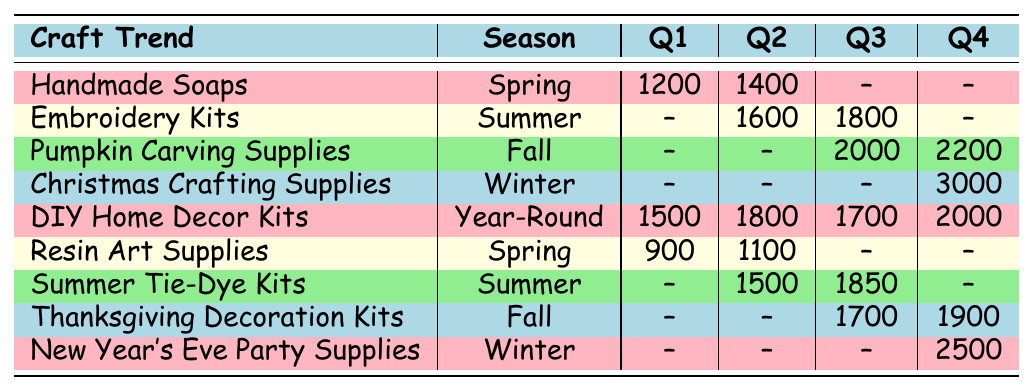What is the total sales of Handmade Soaps in Spring? From the table, we see that the sales for Handmade Soaps in Spring are listed as 1200 in Q1 and 1400 in Q2. Adding these together gives 1200 + 1400 = 2600.
Answer: 2600 Which quarter had the highest sales for Thanksgiving Decoration Kits? Looking at the sales data for Thanksgiving Decoration Kits, we find that Q3 has 1700 and Q4 has 1900. Comparing these values, Q4 has the highest sales.
Answer: Q4 What is the average sales for DIY Home Decor Kits throughout the year? To find the average, we first sum the quarterly sales: 1500 + 1800 + 1700 + 2000 = 7000. Next, we divide by the number of quarters, which is 4. Thus, the average is 7000 / 4 = 1750.
Answer: 1750 Did sales for Christmas Crafting Supplies occur in any quarter besides Q4? The table shows that sales for Christmas Crafting Supplies are only recorded in Q4, where there are 3000 sales, and there are no entries for Q1, Q2, or Q3. Therefore, it is false that there were sales in other quarters.
Answer: No Which season has the highest total sales among the listed trends? We need to calculate the total sales for each season: Spring (1200 + 1400 + 900 + 1100 = 4100), Summer (1600 + 1800 + 1500 + 1850 = 6750), Fall (2000 + 2200 + 1700 + 1900 = 8000), Winter (3000 + 2500 = 5500). Fall has the highest total sales of 8000.
Answer: Fall What is the sales difference between Q2 and Q3 for Summer Tie-Dye Kits? The sales for Summer Tie-Dye Kits show 1500 in Q2 and 1850 in Q3. To find the difference, we subtract Q2 from Q3: 1850 - 1500 = 350.
Answer: 350 Which craft trend had consistent sales performance across all quarters? Looking through the table, only DIY Home Decor Kits show sales in each quarter. All other trends have missing sales. This indicates that DIY Home Decor Kits had consistent performance year-round.
Answer: DIY Home Decor Kits Is there any sold item in Q1 for Winter? Reviewing the sales for Winter, we see that both New Year's Eve Party Supplies and Christmas Crafting Supplies show no sales in Q1 as all entries are marked as null. Hence, the statement is true.
Answer: No 